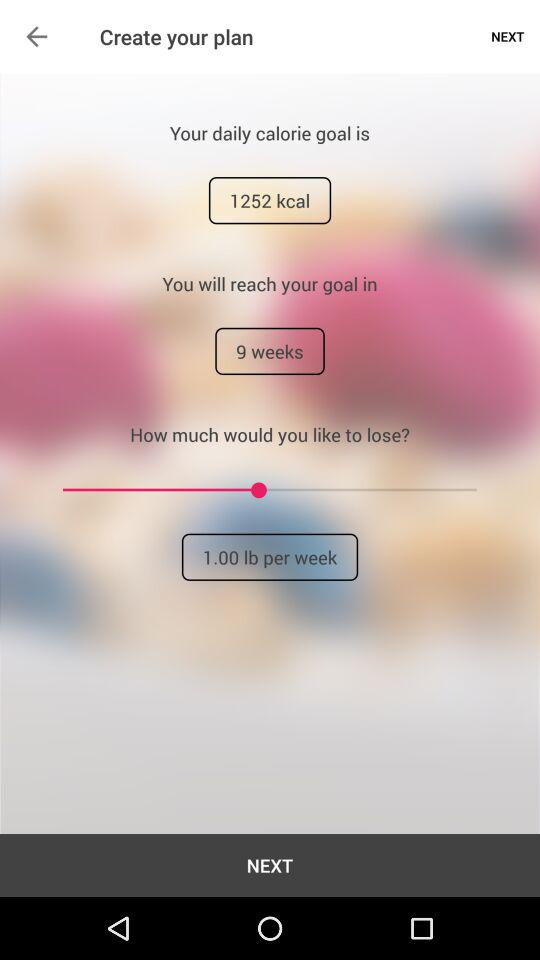How many weeks will it take to reach my goal?
Answer the question using a single word or phrase. 9 weeks 